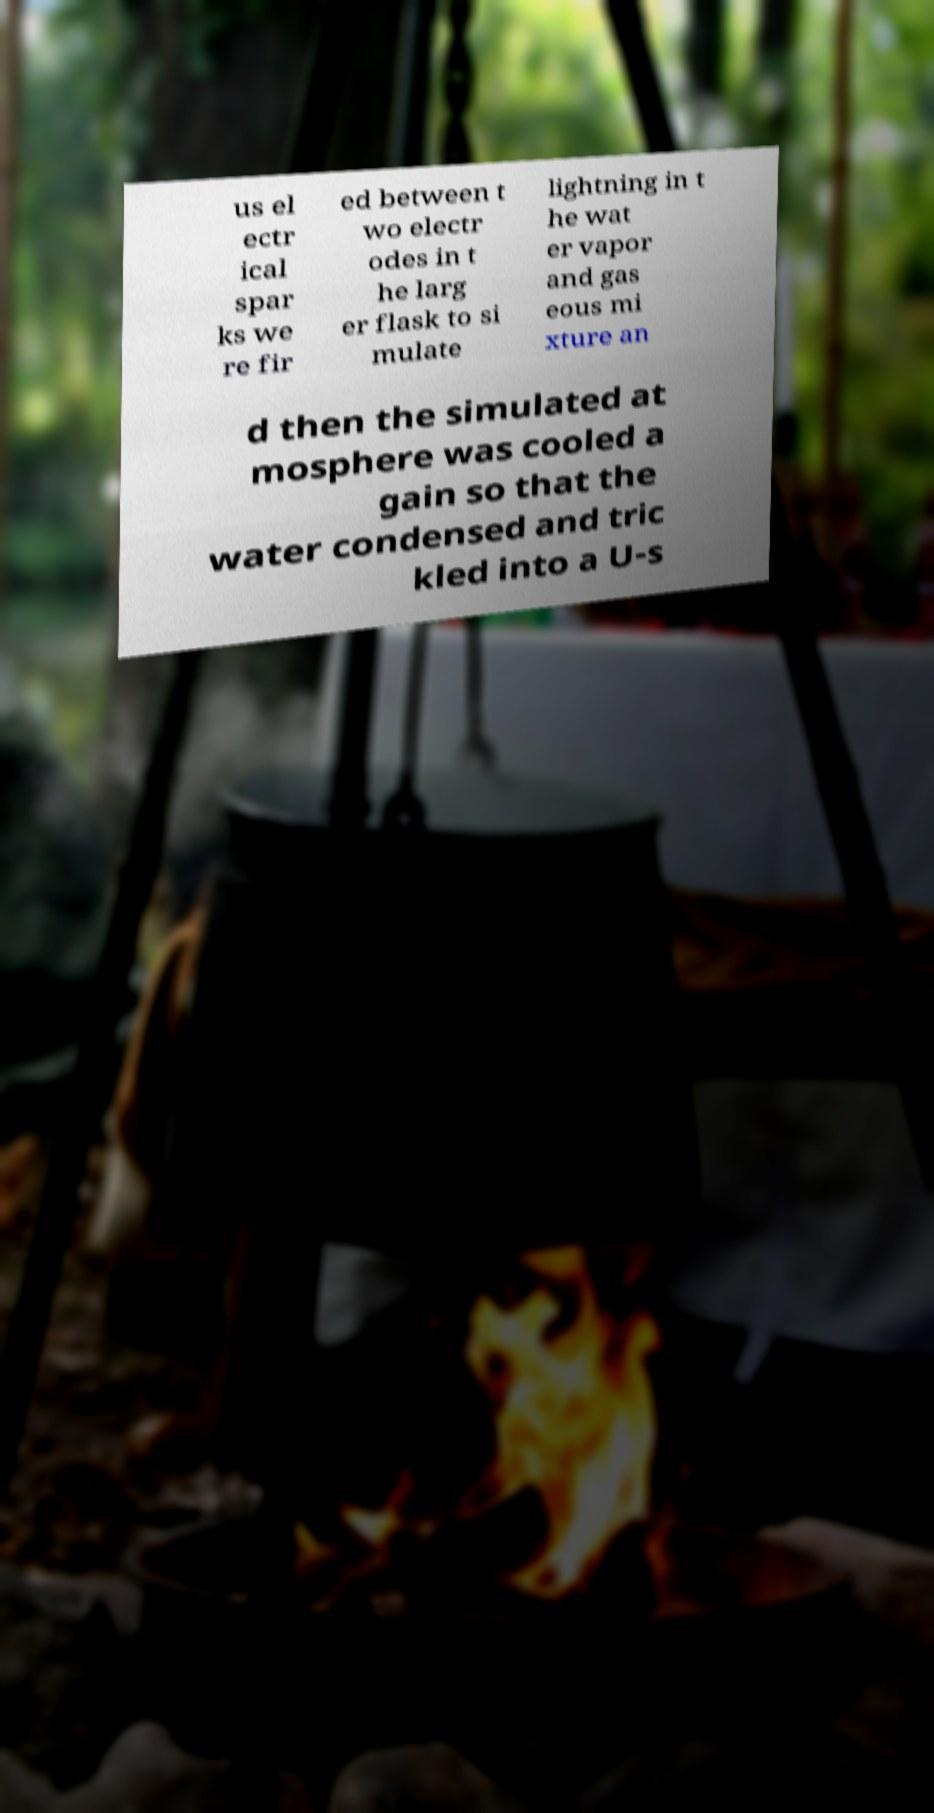What messages or text are displayed in this image? I need them in a readable, typed format. us el ectr ical spar ks we re fir ed between t wo electr odes in t he larg er flask to si mulate lightning in t he wat er vapor and gas eous mi xture an d then the simulated at mosphere was cooled a gain so that the water condensed and tric kled into a U-s 